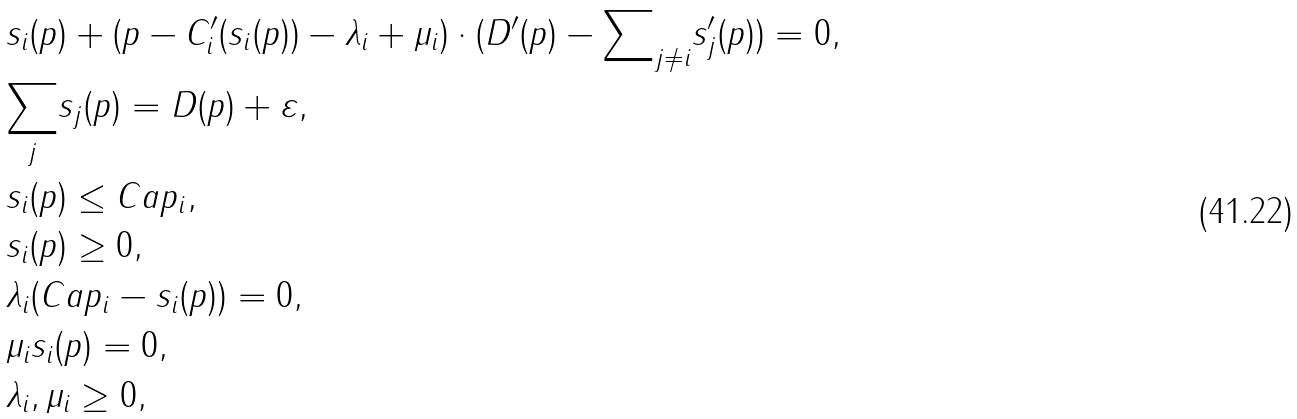<formula> <loc_0><loc_0><loc_500><loc_500>& s _ { i } ( p ) + ( p - C _ { i } ^ { \prime } ( s _ { i } ( p ) ) - \lambda _ { i } + \mu _ { i } ) \cdot ( D ^ { \prime } ( p ) - { \sum } _ { j \ne i } s _ { j } ^ { \prime } ( p ) ) = 0 , \\ & { \sum _ { j } } s _ { j } ( p ) = D ( p ) + \varepsilon , \\ & s _ { i } ( p ) \leq C a p _ { i } , \\ & s _ { i } ( p ) \geq 0 , \\ & \lambda _ { i } ( C a p _ { i } - s _ { i } ( p ) ) = 0 , \\ & \mu _ { i } s _ { i } ( p ) = 0 , \\ & \lambda _ { i } , \mu _ { i } \geq 0 ,</formula> 